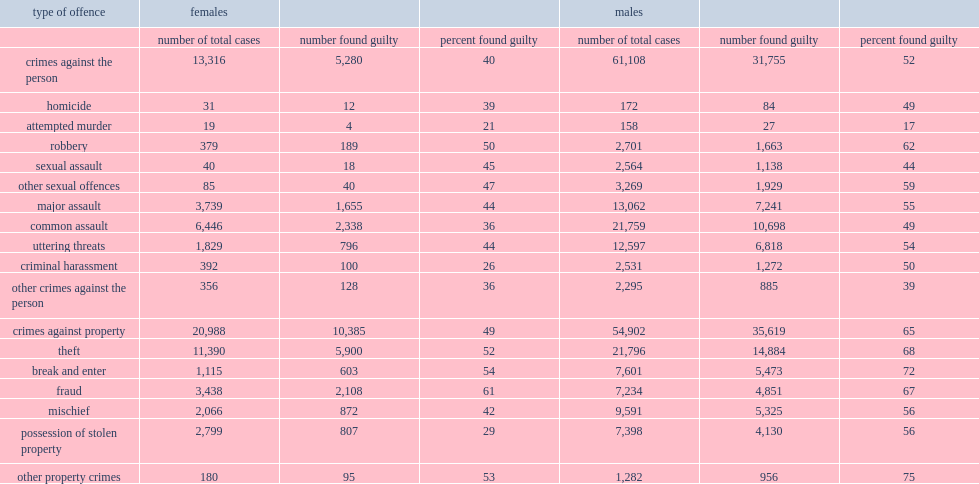In 2015/2016, how many completed adult criminal court cases are related to violent crimes? 74424. Which group of criminal court cases for violent crimes adult was less likely to result in guilty decisions? male or female. Females. What percent of cases involving a female were found guilty for criminal arassment cases. 26.0. 